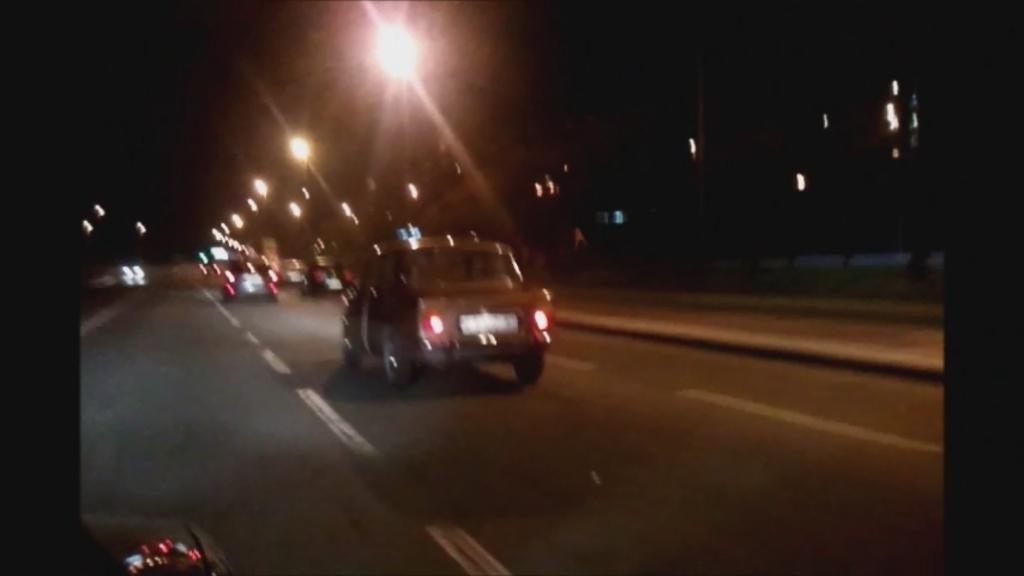Please provide a concise description of this image. In the center of the image we can see a few vehicles on the road. At the bottom left side of the image, we can see some object. In the background, we can see lights and a few other objects. And we can see the black colored border on the right and left side of the image. 